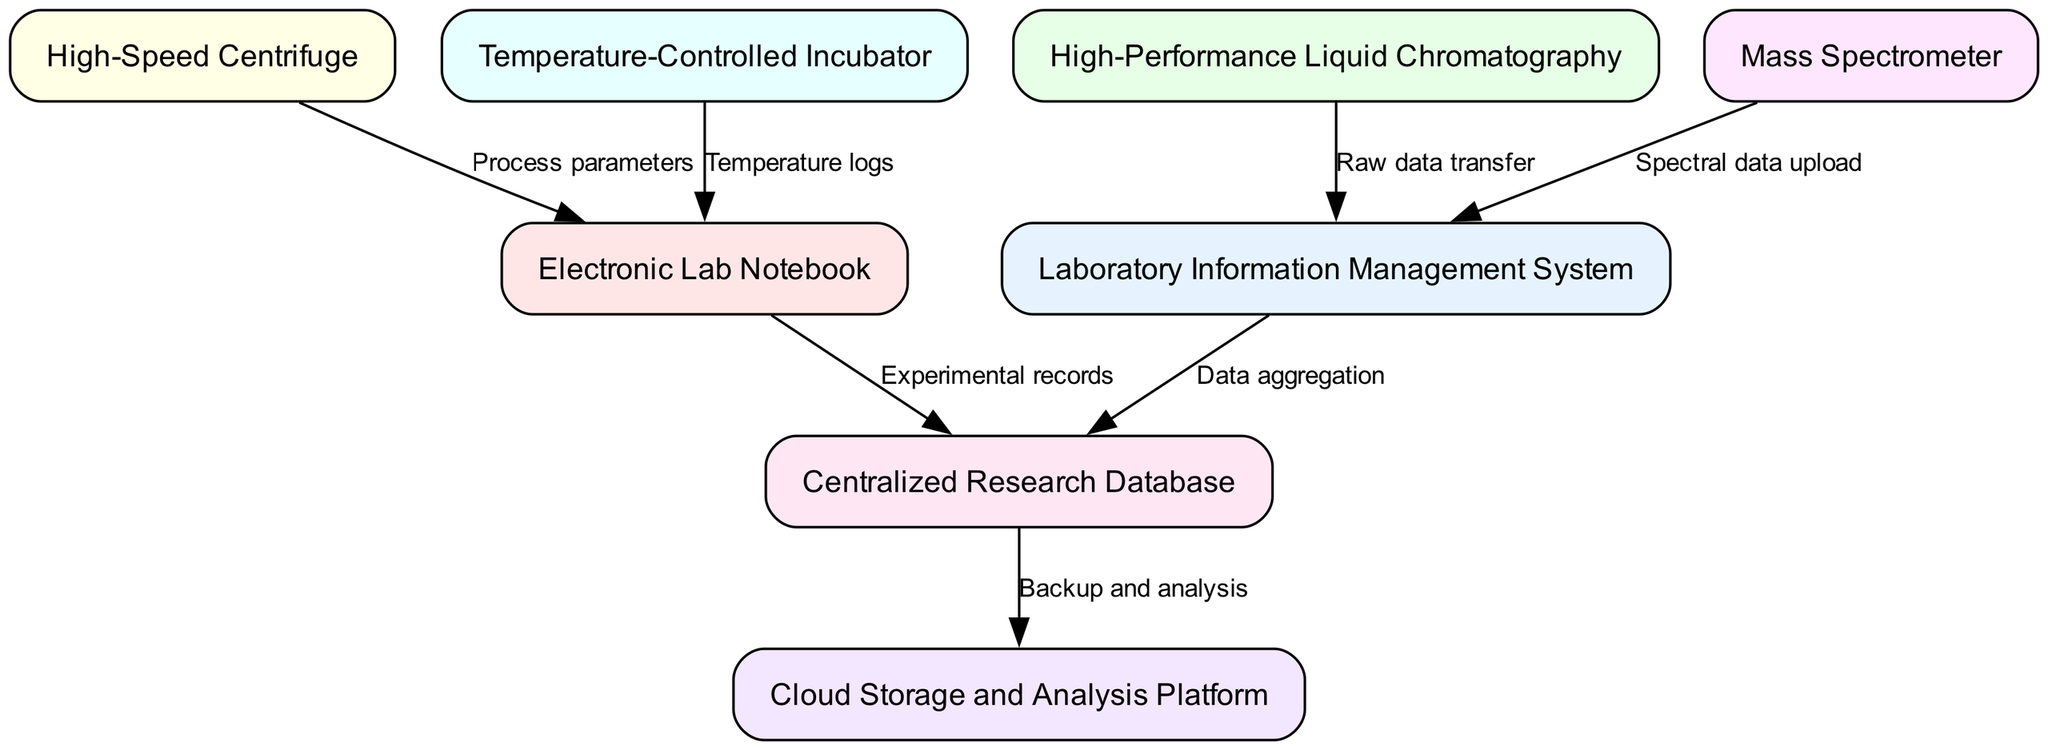What is the total number of nodes in the diagram? The diagram includes various entities such as lab equipment and information systems, each represented as a unique node. Counting them reveals there are a total of eight nodes: Laboratory Information Management System, Electronic Lab Notebook, High-Performance Liquid Chromatography, Mass Spectrometer, High-Speed Centrifuge, Temperature-Controlled Incubator, Centralized Research Database, and Cloud Storage and Analysis Platform.
Answer: 8 What type of data is transferred from the HPLC to the LIMS? According to the diagram, HPLC connects to LIMS through an edge labeled "Raw data transfer." This indicates the specific type of data being transferred is raw data.
Answer: Raw data Which equipment sends temperature logs to the ELN? The diagram specifies an edge leading to ELN labeled "Temperature logs," which clearly indicates that the Temperature-Controlled Incubator is the equipment that provides these logs.
Answer: Incubator How many edges are shown in the diagram? Each edge in the diagram signifies a data flow or relationship between nodes. Counting the connections illustrates there are a total of seven edges connecting the various nodes for data transfer and processes.
Answer: 7 Which systems receive aggregated data from the LIMS? In the diagram, there's an edge leading from LIMS to a node labeled "Database," signifying that the Database is the system where the aggregated data from LIMS is sent.
Answer: Database What is the final destination of the data from the Database according to the diagram? The edge from the Database is directed to a node labeled "Cloud," indicating that the final destination for the data from the Database is the Cloud for backup and analysis.
Answer: Cloud Which two systems interact directly with the Database? The diagram shows two edges leading to the Database - one from LIMS marked "Data aggregation" and another from ELN labeled "Experimental records." This indicates both LIMS and ELN interact directly with the Database.
Answer: LIMS and ELN What is the nature of the data that the Mass Spectrometer sends to the LIMS? The diagram specifies an edge coming from the Mass Spectrometer to LIMS, titled "Spectral data upload," implying that the data type being uploaded is spectral data.
Answer: Spectral data 